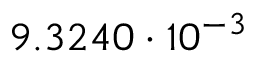Convert formula to latex. <formula><loc_0><loc_0><loc_500><loc_500>9 . 3 2 4 0 \cdot 1 0 ^ { - 3 }</formula> 